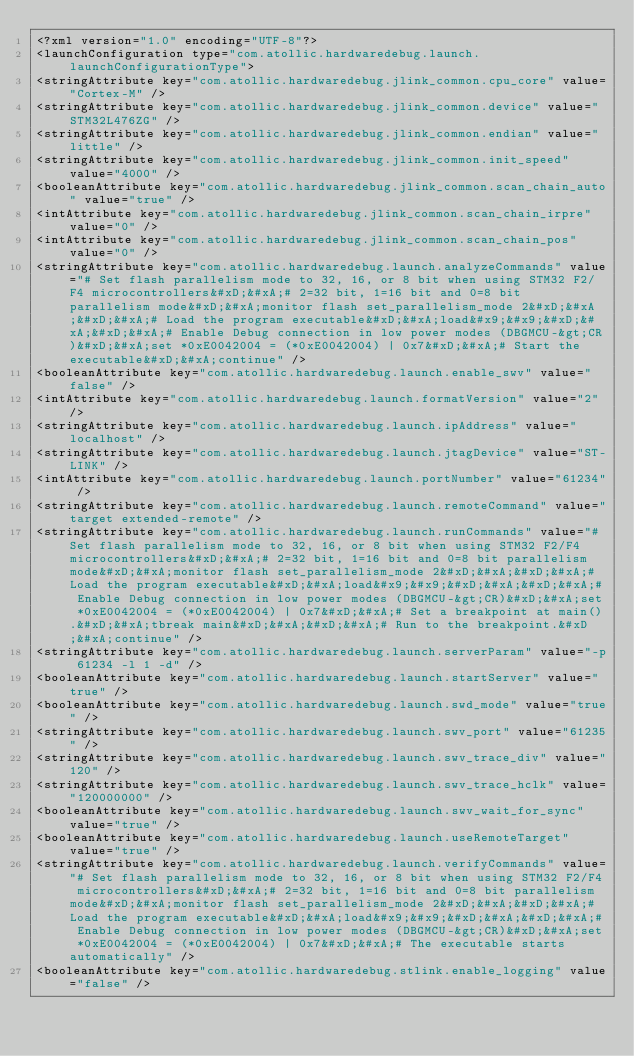Convert code to text. <code><loc_0><loc_0><loc_500><loc_500><_XML_><?xml version="1.0" encoding="UTF-8"?>
<launchConfiguration type="com.atollic.hardwaredebug.launch.launchConfigurationType">
<stringAttribute key="com.atollic.hardwaredebug.jlink_common.cpu_core" value="Cortex-M" />
<stringAttribute key="com.atollic.hardwaredebug.jlink_common.device" value="STM32L476ZG" />
<stringAttribute key="com.atollic.hardwaredebug.jlink_common.endian" value="little" />
<stringAttribute key="com.atollic.hardwaredebug.jlink_common.init_speed" value="4000" />
<booleanAttribute key="com.atollic.hardwaredebug.jlink_common.scan_chain_auto" value="true" />
<intAttribute key="com.atollic.hardwaredebug.jlink_common.scan_chain_irpre" value="0" />
<intAttribute key="com.atollic.hardwaredebug.jlink_common.scan_chain_pos" value="0" />
<stringAttribute key="com.atollic.hardwaredebug.launch.analyzeCommands" value="# Set flash parallelism mode to 32, 16, or 8 bit when using STM32 F2/F4 microcontrollers&#xD;&#xA;# 2=32 bit, 1=16 bit and 0=8 bit parallelism mode&#xD;&#xA;monitor flash set_parallelism_mode 2&#xD;&#xA;&#xD;&#xA;# Load the program executable&#xD;&#xA;load&#x9;&#x9;&#xD;&#xA;&#xD;&#xA;# Enable Debug connection in low power modes (DBGMCU-&gt;CR)&#xD;&#xA;set *0xE0042004 = (*0xE0042004) | 0x7&#xD;&#xA;# Start the executable&#xD;&#xA;continue" />
<booleanAttribute key="com.atollic.hardwaredebug.launch.enable_swv" value="false" />
<intAttribute key="com.atollic.hardwaredebug.launch.formatVersion" value="2" />
<stringAttribute key="com.atollic.hardwaredebug.launch.ipAddress" value="localhost" />
<stringAttribute key="com.atollic.hardwaredebug.launch.jtagDevice" value="ST-LINK" />
<intAttribute key="com.atollic.hardwaredebug.launch.portNumber" value="61234" />
<stringAttribute key="com.atollic.hardwaredebug.launch.remoteCommand" value="target extended-remote" />
<stringAttribute key="com.atollic.hardwaredebug.launch.runCommands" value="# Set flash parallelism mode to 32, 16, or 8 bit when using STM32 F2/F4 microcontrollers&#xD;&#xA;# 2=32 bit, 1=16 bit and 0=8 bit parallelism mode&#xD;&#xA;monitor flash set_parallelism_mode 2&#xD;&#xA;&#xD;&#xA;# Load the program executable&#xD;&#xA;load&#x9;&#x9;&#xD;&#xA;&#xD;&#xA;# Enable Debug connection in low power modes (DBGMCU-&gt;CR)&#xD;&#xA;set *0xE0042004 = (*0xE0042004) | 0x7&#xD;&#xA;# Set a breakpoint at main().&#xD;&#xA;tbreak main&#xD;&#xA;&#xD;&#xA;# Run to the breakpoint.&#xD;&#xA;continue" />
<stringAttribute key="com.atollic.hardwaredebug.launch.serverParam" value="-p 61234 -l 1 -d" />
<booleanAttribute key="com.atollic.hardwaredebug.launch.startServer" value="true" />
<booleanAttribute key="com.atollic.hardwaredebug.launch.swd_mode" value="true" />
<stringAttribute key="com.atollic.hardwaredebug.launch.swv_port" value="61235" />
<stringAttribute key="com.atollic.hardwaredebug.launch.swv_trace_div" value="120" />
<stringAttribute key="com.atollic.hardwaredebug.launch.swv_trace_hclk" value="120000000" />
<booleanAttribute key="com.atollic.hardwaredebug.launch.swv_wait_for_sync" value="true" />
<booleanAttribute key="com.atollic.hardwaredebug.launch.useRemoteTarget" value="true" />
<stringAttribute key="com.atollic.hardwaredebug.launch.verifyCommands" value="# Set flash parallelism mode to 32, 16, or 8 bit when using STM32 F2/F4 microcontrollers&#xD;&#xA;# 2=32 bit, 1=16 bit and 0=8 bit parallelism mode&#xD;&#xA;monitor flash set_parallelism_mode 2&#xD;&#xA;&#xD;&#xA;# Load the program executable&#xD;&#xA;load&#x9;&#x9;&#xD;&#xA;&#xD;&#xA;# Enable Debug connection in low power modes (DBGMCU-&gt;CR)&#xD;&#xA;set *0xE0042004 = (*0xE0042004) | 0x7&#xD;&#xA;# The executable starts automatically" />
<booleanAttribute key="com.atollic.hardwaredebug.stlink.enable_logging" value="false" /></code> 